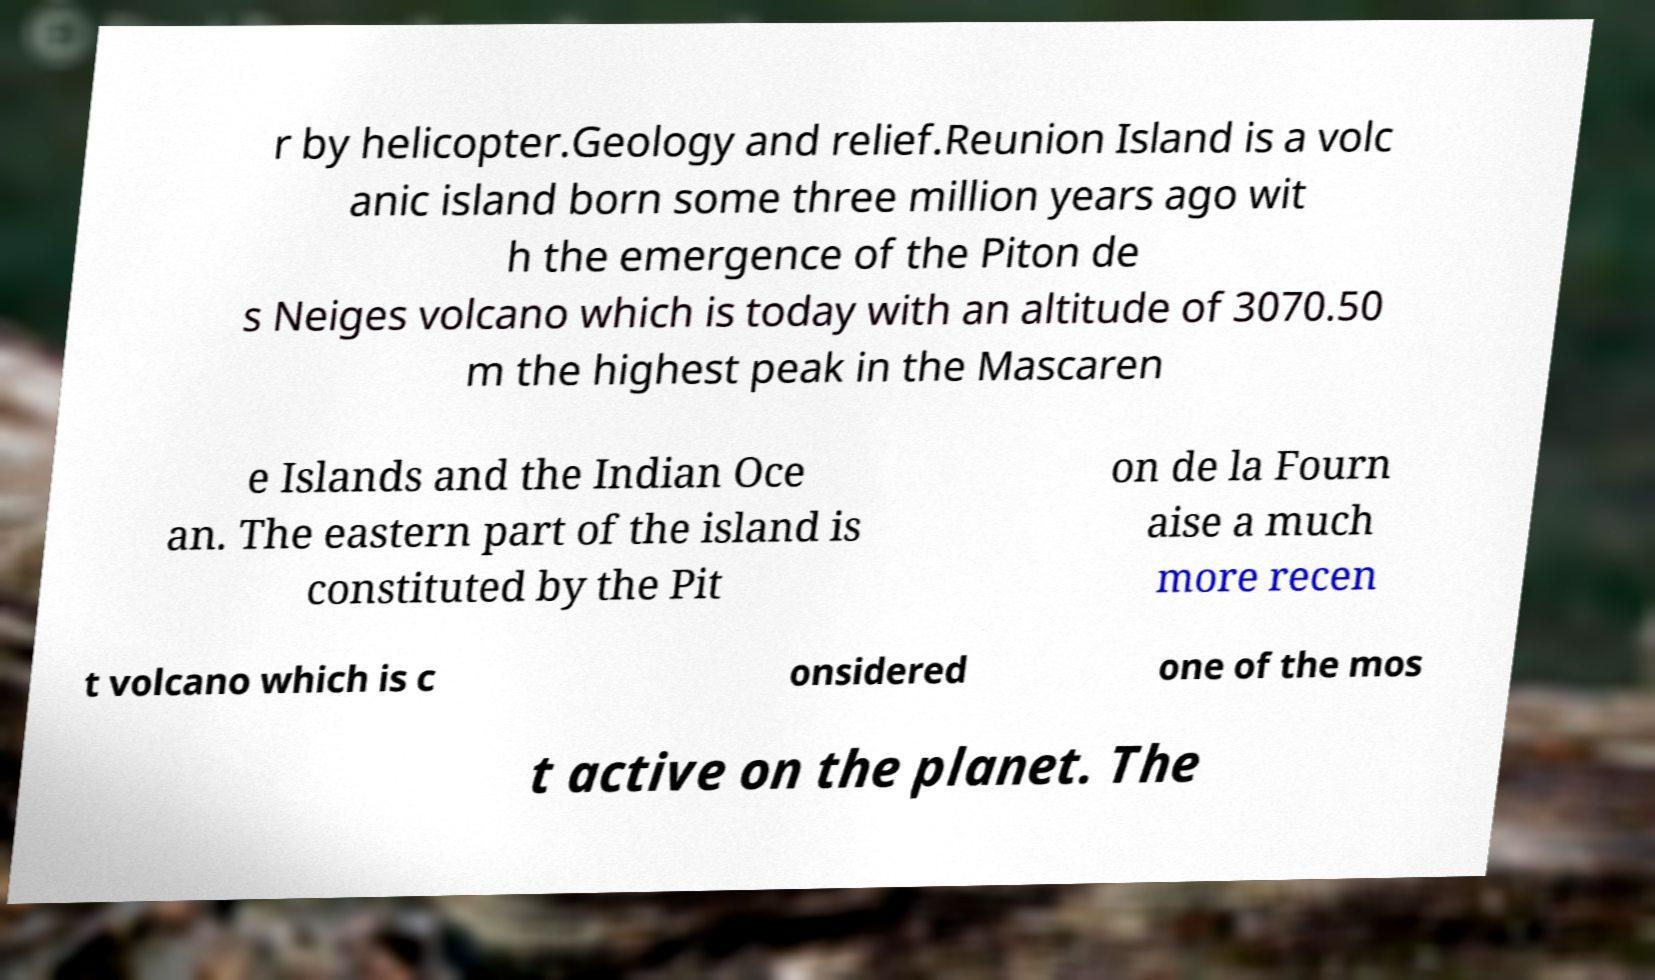Please identify and transcribe the text found in this image. r by helicopter.Geology and relief.Reunion Island is a volc anic island born some three million years ago wit h the emergence of the Piton de s Neiges volcano which is today with an altitude of 3070.50 m the highest peak in the Mascaren e Islands and the Indian Oce an. The eastern part of the island is constituted by the Pit on de la Fourn aise a much more recen t volcano which is c onsidered one of the mos t active on the planet. The 